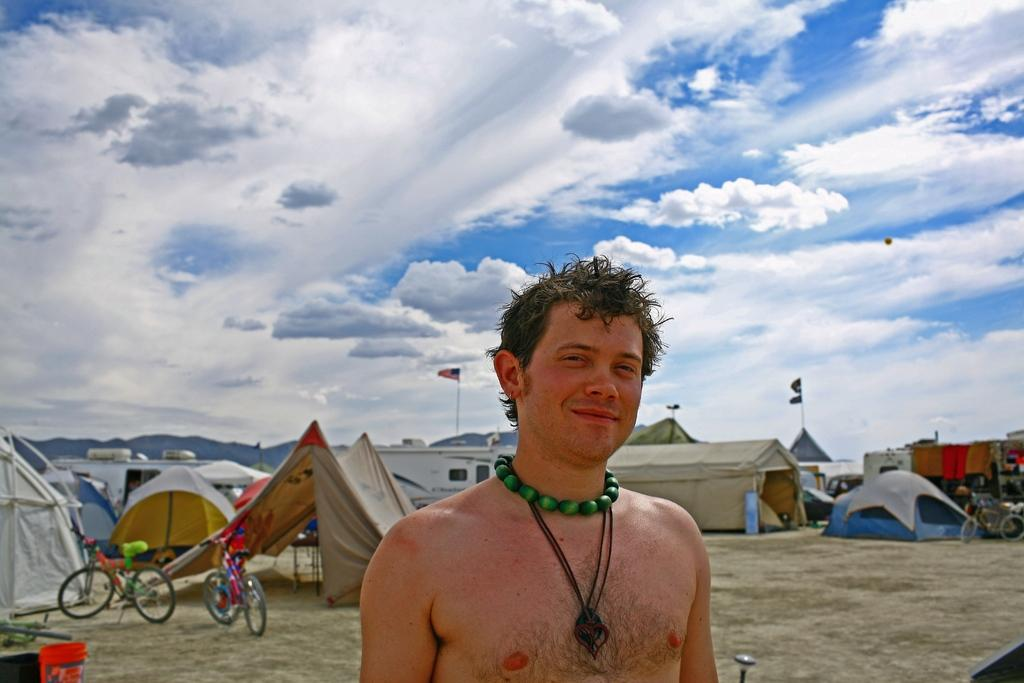Who is the main subject in the foreground of the image? There is a man in the foreground of the image. What can be seen in the background of the image? In the background of the image, there are bicycles, tents, vehicles, flags, and the sky. What is the condition of the sky in the image? The sky is visible in the background of the image, and there are clouds present. Can you tell me how many pages are in the book that the man is reading in the image? There is no book or pages visible in the image; the man is not holding or reading anything. Is there a lake present in the image? There is no lake present in the image; the background features bicycles, tents, vehicles, flags, and the sky. 